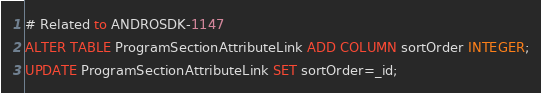<code> <loc_0><loc_0><loc_500><loc_500><_SQL_># Related to ANDROSDK-1147
ALTER TABLE ProgramSectionAttributeLink ADD COLUMN sortOrder INTEGER;
UPDATE ProgramSectionAttributeLink SET sortOrder=_id;</code> 